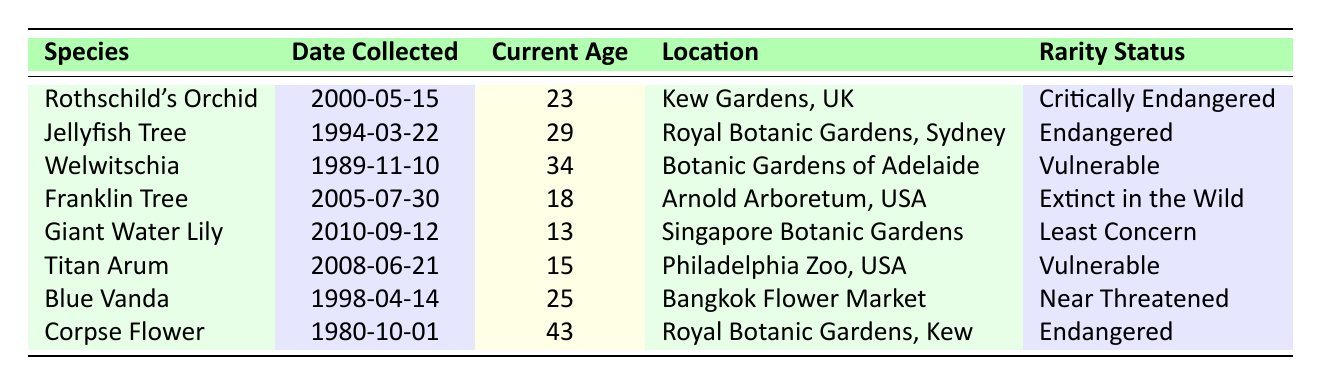What is the current age of Rothschild's Orchid? The table lists the current age of Rothschild's Orchid as 23.
Answer: 23 How many rare plant species are located in Australia? There are three species listed in the table that are collected in Australia: Jellyfish Tree, Welwitschia, and Titan Arum.
Answer: 3 What is the sum of the current ages of all plants listed in the table? Adding up the current ages: 23 + 29 + 34 + 18 + 13 + 15 + 25 + 43 equals  230.
Answer: 230 Is the Franklin Tree considered critically endangered? The table indicates that the Franklin Tree is listed as "Extinct in the Wild," therefore it is not critically endangered.
Answer: No Which plant species has the highest current age, and what is that age? Reviewing the ages, Corpse Flower has the highest age at 43.
Answer: Corpse Flower, 43 What is the average age of the endangered plants in the table? The endangered plants are Jellyfish Tree (29), Corpse Flower (43), and Franklin Tree (18). Summing these ages gives 90, and dividing by the number of plants (3) yields an average of 30.
Answer: 30 Are there any plants collected after the year 2000 in the table? The table shows Rothschild's Orchid (2000), Giant Water Lily (2010), and Titan Arum (2008) were collected after 2000, confirming there are plants collected after this year.
Answer: Yes What is the location of the Welwitschia plant? The table states that Welwitschia is located in Botanic Gardens of Adelaide, Australia.
Answer: Botanic Gardens of Adelaide, Australia What is the rarity status of the Giant Water Lily? According to the table, the rarity status of the Giant Water Lily is listed as "Least Concern."
Answer: Least Concern 